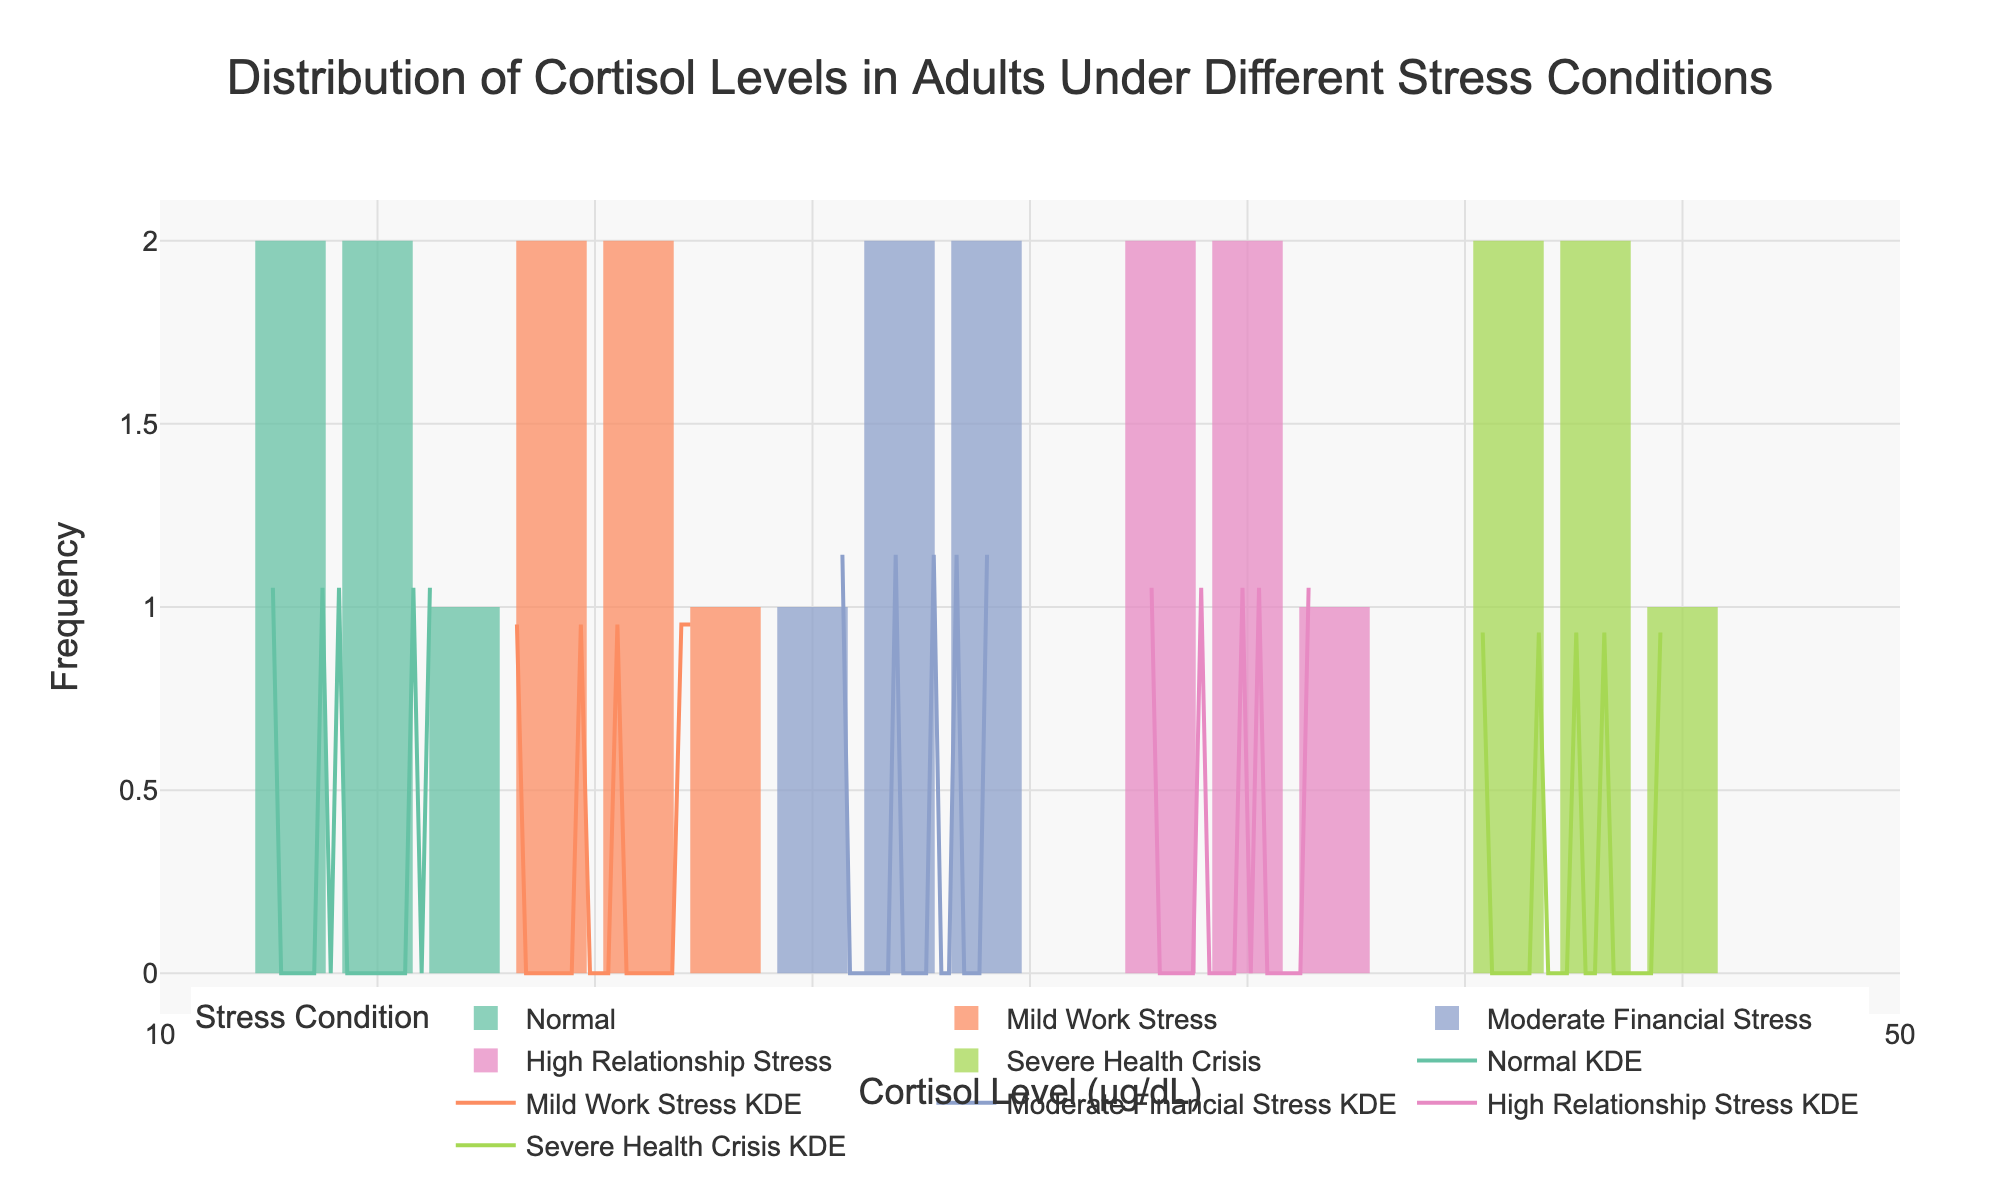What is the title of the figure? The title is typically located at the top center of the figure and it summarizes the overall content and purpose of the visualization. Here, the title reads "Distribution of Cortisol Levels in Adults Under Different Stress Conditions."
Answer: Distribution of Cortisol Levels in Adults Under Different Stress Conditions How many stress conditions are there in the dataset? To determine the number of stress conditions, look at the legend or count the distinct bar colors and corresponding KDE lines. The legend indicates five distinct stress conditions: Normal, Mild Work Stress, Moderate Financial Stress, High Relationship Stress, and Severe Health Crisis.
Answer: 5 Which stress condition shows the highest cortisol level range? Observe the x-axis range covered by each stress condition. The histogram for Severe Health Crisis spans the highest range, up to around 45 μg/dL.
Answer: Severe Health Crisis What is the x-axis label? The x-axis label provides information about what the variable on the x-axis represents. Here, it reads "Cortisol Level (μg/dL)," indicating that the x-axis shows the cortisol levels measured in micrograms per deciliter.
Answer: Cortisol Level (μg/dL) Which two stress conditions have overlapping KDE curves? Examine the KDE curves in the figure closely to see where they overlap. The KDE curves for Moderate Financial Stress (purple) and High Relationship Stress (pink) overlap significantly in the range of approximately 26 to 30 μg/dL.
Answer: Moderate Financial Stress and High Relationship Stress Between "Mild Work Stress" and "Moderate Financial Stress," which condition has a wider distribution of cortisol levels? Compare the width of the histograms and KDE plots for "Mild Work Stress" and "Moderate Financial Stress." The bars for "Moderate Financial Stress" (purple) cover a wider range on the x-axis than those for "Mild Work Stress" (orange), indicating a wider distribution.
Answer: Moderate Financial Stress How does the cortisol level distribution under "Normal" conditions compare with "High Relationship Stress"? Evaluate the range and shape of the histogram and KDE for both conditions. "Normal" conditions have a narrower and lower range (around 12 to 16 μg/dL) compared to "High Relationship Stress," which has a wider and higher range (up to around 36 μg/dL).
Answer: "Normal" has a narrower and lower range than "High Relationship Stress." What is the color used to represent "Severe Health Crisis" in the figure? The color assigned to each stress condition is indicated in the legend. The "Severe Health Crisis" condition uses a green color (#a6d854).
Answer: Green Which stress condition appears to have the highest peak in the KDE curve? Identify which KDE curve reaches the highest point. The KDE for "Severe Health Crisis" (green) appears to have the highest peak, indicating a higher density of cortisol levels around its mode.
Answer: Severe Health Crisis 